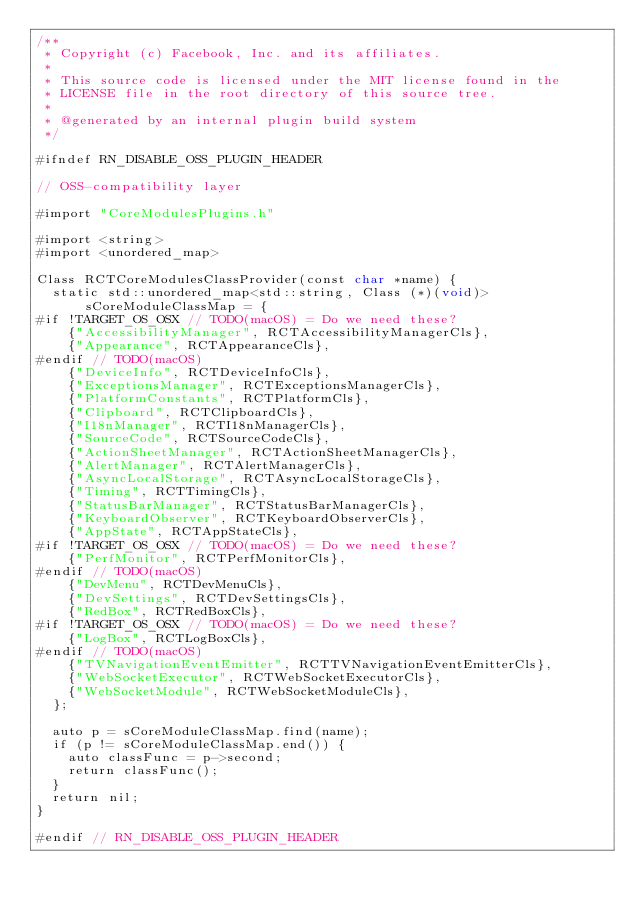Convert code to text. <code><loc_0><loc_0><loc_500><loc_500><_ObjectiveC_>/**
 * Copyright (c) Facebook, Inc. and its affiliates.
 *
 * This source code is licensed under the MIT license found in the
 * LICENSE file in the root directory of this source tree.
 *
 * @generated by an internal plugin build system
 */

#ifndef RN_DISABLE_OSS_PLUGIN_HEADER

// OSS-compatibility layer

#import "CoreModulesPlugins.h"

#import <string>
#import <unordered_map>

Class RCTCoreModulesClassProvider(const char *name) {
  static std::unordered_map<std::string, Class (*)(void)> sCoreModuleClassMap = {
#if !TARGET_OS_OSX // TODO(macOS) = Do we need these?
    {"AccessibilityManager", RCTAccessibilityManagerCls},
    {"Appearance", RCTAppearanceCls},
#endif // TODO(macOS)
    {"DeviceInfo", RCTDeviceInfoCls},
    {"ExceptionsManager", RCTExceptionsManagerCls},
    {"PlatformConstants", RCTPlatformCls},
    {"Clipboard", RCTClipboardCls},
    {"I18nManager", RCTI18nManagerCls},
    {"SourceCode", RCTSourceCodeCls},
    {"ActionSheetManager", RCTActionSheetManagerCls},
    {"AlertManager", RCTAlertManagerCls},
    {"AsyncLocalStorage", RCTAsyncLocalStorageCls},
    {"Timing", RCTTimingCls},
    {"StatusBarManager", RCTStatusBarManagerCls},
    {"KeyboardObserver", RCTKeyboardObserverCls},
    {"AppState", RCTAppStateCls},
#if !TARGET_OS_OSX // TODO(macOS) = Do we need these?
    {"PerfMonitor", RCTPerfMonitorCls},
#endif // TODO(macOS)
    {"DevMenu", RCTDevMenuCls},
    {"DevSettings", RCTDevSettingsCls},
    {"RedBox", RCTRedBoxCls},
#if !TARGET_OS_OSX // TODO(macOS) = Do we need these?
    {"LogBox", RCTLogBoxCls},
#endif // TODO(macOS)
    {"TVNavigationEventEmitter", RCTTVNavigationEventEmitterCls},
    {"WebSocketExecutor", RCTWebSocketExecutorCls},
    {"WebSocketModule", RCTWebSocketModuleCls},
  };

  auto p = sCoreModuleClassMap.find(name);
  if (p != sCoreModuleClassMap.end()) {
    auto classFunc = p->second;
    return classFunc();
  }
  return nil;
}

#endif // RN_DISABLE_OSS_PLUGIN_HEADER
</code> 